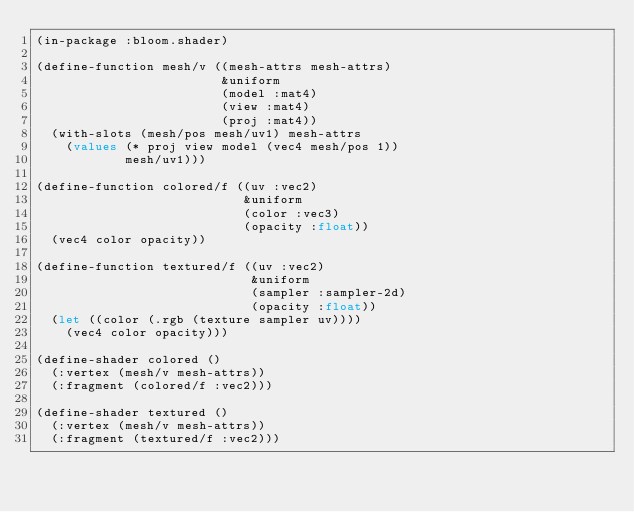<code> <loc_0><loc_0><loc_500><loc_500><_Lisp_>(in-package :bloom.shader)

(define-function mesh/v ((mesh-attrs mesh-attrs)
                         &uniform
                         (model :mat4)
                         (view :mat4)
                         (proj :mat4))
  (with-slots (mesh/pos mesh/uv1) mesh-attrs
    (values (* proj view model (vec4 mesh/pos 1))
            mesh/uv1)))

(define-function colored/f ((uv :vec2)
                            &uniform
                            (color :vec3)
                            (opacity :float))
  (vec4 color opacity))

(define-function textured/f ((uv :vec2)
                             &uniform
                             (sampler :sampler-2d)
                             (opacity :float))
  (let ((color (.rgb (texture sampler uv))))
    (vec4 color opacity)))

(define-shader colored ()
  (:vertex (mesh/v mesh-attrs))
  (:fragment (colored/f :vec2)))

(define-shader textured ()
  (:vertex (mesh/v mesh-attrs))
  (:fragment (textured/f :vec2)))
</code> 